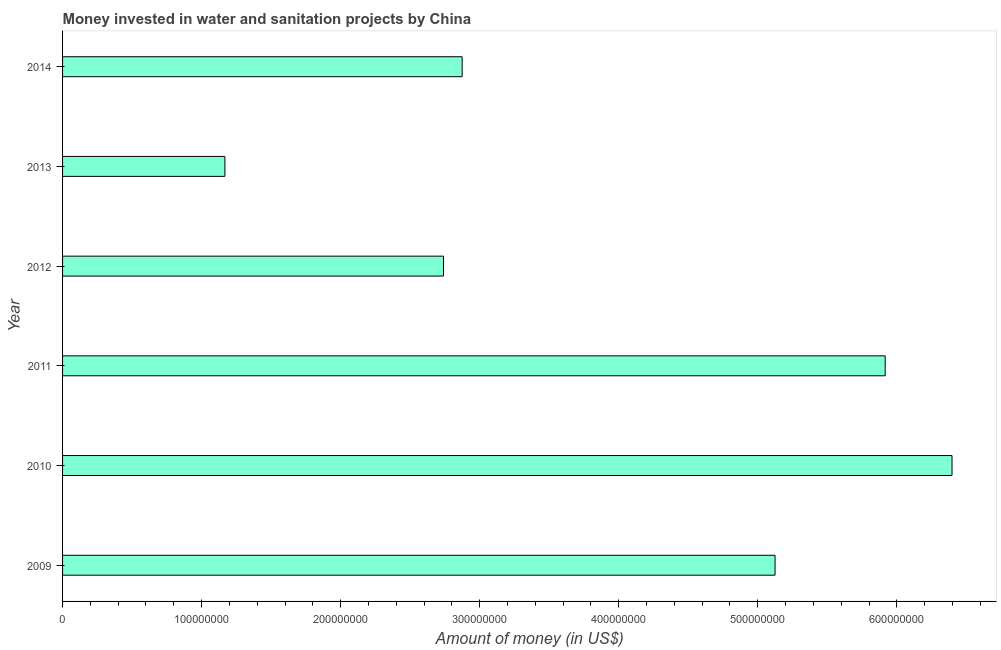Does the graph contain grids?
Provide a short and direct response. No. What is the title of the graph?
Provide a short and direct response. Money invested in water and sanitation projects by China. What is the label or title of the X-axis?
Your answer should be compact. Amount of money (in US$). What is the investment in 2011?
Provide a succinct answer. 5.92e+08. Across all years, what is the maximum investment?
Your answer should be very brief. 6.40e+08. Across all years, what is the minimum investment?
Ensure brevity in your answer.  1.17e+08. In which year was the investment maximum?
Keep it short and to the point. 2010. In which year was the investment minimum?
Give a very brief answer. 2013. What is the sum of the investment?
Your answer should be compact. 2.42e+09. What is the difference between the investment in 2011 and 2012?
Your answer should be compact. 3.18e+08. What is the average investment per year?
Make the answer very short. 4.04e+08. What is the median investment?
Make the answer very short. 4.00e+08. What is the ratio of the investment in 2010 to that in 2011?
Ensure brevity in your answer.  1.08. What is the difference between the highest and the second highest investment?
Your response must be concise. 4.81e+07. Is the sum of the investment in 2012 and 2014 greater than the maximum investment across all years?
Provide a succinct answer. No. What is the difference between the highest and the lowest investment?
Your answer should be very brief. 5.23e+08. In how many years, is the investment greater than the average investment taken over all years?
Your answer should be compact. 3. How many bars are there?
Offer a very short reply. 6. Are all the bars in the graph horizontal?
Offer a terse response. Yes. How many years are there in the graph?
Offer a very short reply. 6. What is the difference between two consecutive major ticks on the X-axis?
Give a very brief answer. 1.00e+08. What is the Amount of money (in US$) of 2009?
Ensure brevity in your answer.  5.12e+08. What is the Amount of money (in US$) in 2010?
Provide a succinct answer. 6.40e+08. What is the Amount of money (in US$) of 2011?
Your response must be concise. 5.92e+08. What is the Amount of money (in US$) of 2012?
Provide a succinct answer. 2.74e+08. What is the Amount of money (in US$) in 2013?
Keep it short and to the point. 1.17e+08. What is the Amount of money (in US$) in 2014?
Keep it short and to the point. 2.87e+08. What is the difference between the Amount of money (in US$) in 2009 and 2010?
Provide a short and direct response. -1.27e+08. What is the difference between the Amount of money (in US$) in 2009 and 2011?
Ensure brevity in your answer.  -7.92e+07. What is the difference between the Amount of money (in US$) in 2009 and 2012?
Make the answer very short. 2.38e+08. What is the difference between the Amount of money (in US$) in 2009 and 2013?
Make the answer very short. 3.96e+08. What is the difference between the Amount of money (in US$) in 2009 and 2014?
Give a very brief answer. 2.25e+08. What is the difference between the Amount of money (in US$) in 2010 and 2011?
Ensure brevity in your answer.  4.81e+07. What is the difference between the Amount of money (in US$) in 2010 and 2012?
Provide a succinct answer. 3.66e+08. What is the difference between the Amount of money (in US$) in 2010 and 2013?
Give a very brief answer. 5.23e+08. What is the difference between the Amount of money (in US$) in 2010 and 2014?
Provide a succinct answer. 3.52e+08. What is the difference between the Amount of money (in US$) in 2011 and 2012?
Provide a short and direct response. 3.18e+08. What is the difference between the Amount of money (in US$) in 2011 and 2013?
Your response must be concise. 4.75e+08. What is the difference between the Amount of money (in US$) in 2011 and 2014?
Ensure brevity in your answer.  3.04e+08. What is the difference between the Amount of money (in US$) in 2012 and 2013?
Give a very brief answer. 1.57e+08. What is the difference between the Amount of money (in US$) in 2012 and 2014?
Make the answer very short. -1.34e+07. What is the difference between the Amount of money (in US$) in 2013 and 2014?
Your response must be concise. -1.71e+08. What is the ratio of the Amount of money (in US$) in 2009 to that in 2010?
Make the answer very short. 0.8. What is the ratio of the Amount of money (in US$) in 2009 to that in 2011?
Provide a succinct answer. 0.87. What is the ratio of the Amount of money (in US$) in 2009 to that in 2012?
Ensure brevity in your answer.  1.87. What is the ratio of the Amount of money (in US$) in 2009 to that in 2013?
Provide a short and direct response. 4.39. What is the ratio of the Amount of money (in US$) in 2009 to that in 2014?
Offer a very short reply. 1.78. What is the ratio of the Amount of money (in US$) in 2010 to that in 2011?
Ensure brevity in your answer.  1.08. What is the ratio of the Amount of money (in US$) in 2010 to that in 2012?
Your answer should be very brief. 2.33. What is the ratio of the Amount of money (in US$) in 2010 to that in 2013?
Provide a succinct answer. 5.48. What is the ratio of the Amount of money (in US$) in 2010 to that in 2014?
Ensure brevity in your answer.  2.23. What is the ratio of the Amount of money (in US$) in 2011 to that in 2012?
Ensure brevity in your answer.  2.16. What is the ratio of the Amount of money (in US$) in 2011 to that in 2013?
Offer a terse response. 5.07. What is the ratio of the Amount of money (in US$) in 2011 to that in 2014?
Give a very brief answer. 2.06. What is the ratio of the Amount of money (in US$) in 2012 to that in 2013?
Your response must be concise. 2.35. What is the ratio of the Amount of money (in US$) in 2012 to that in 2014?
Your response must be concise. 0.95. What is the ratio of the Amount of money (in US$) in 2013 to that in 2014?
Keep it short and to the point. 0.41. 